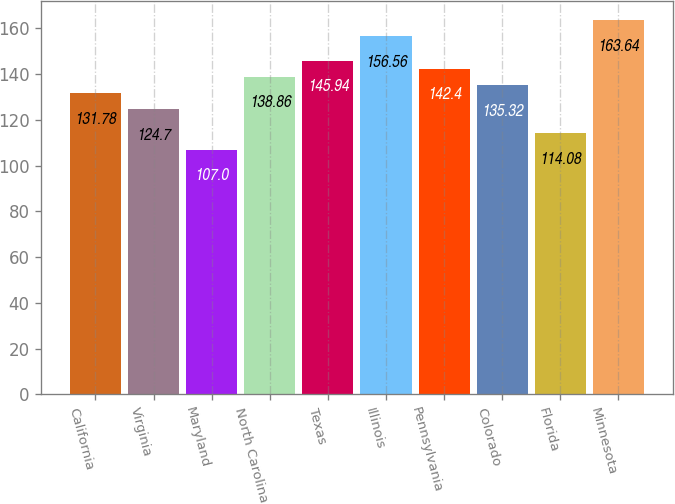Convert chart. <chart><loc_0><loc_0><loc_500><loc_500><bar_chart><fcel>California<fcel>Virginia<fcel>Maryland<fcel>North Carolina<fcel>Texas<fcel>Illinois<fcel>Pennsylvania<fcel>Colorado<fcel>Florida<fcel>Minnesota<nl><fcel>131.78<fcel>124.7<fcel>107<fcel>138.86<fcel>145.94<fcel>156.56<fcel>142.4<fcel>135.32<fcel>114.08<fcel>163.64<nl></chart> 